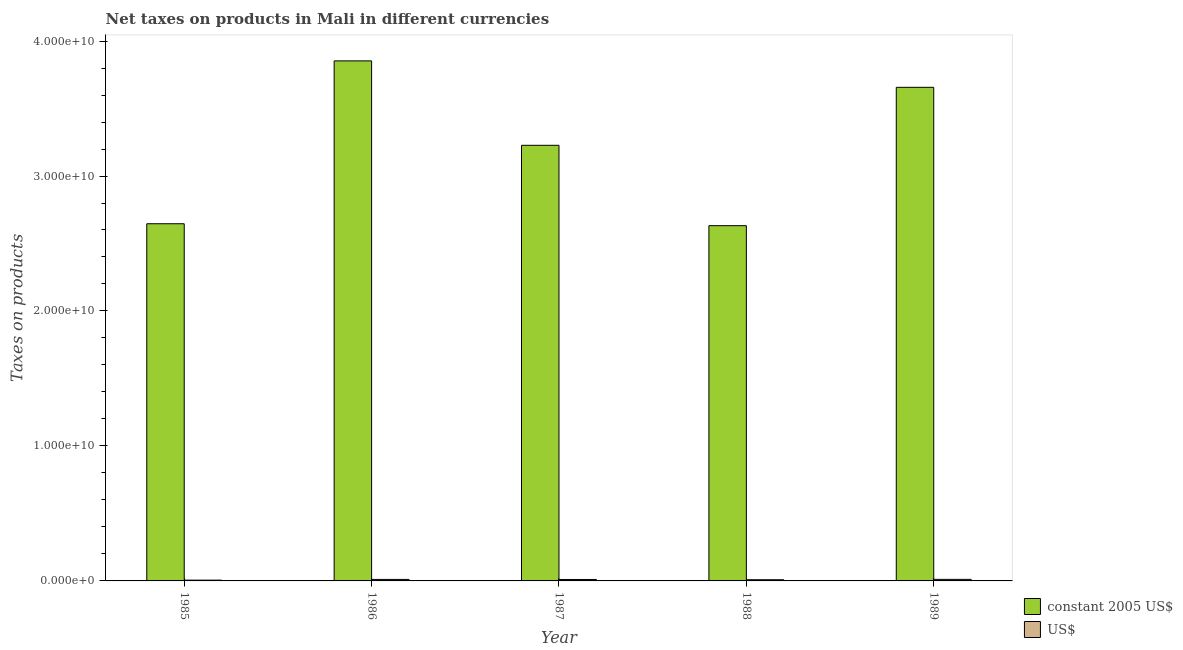How many different coloured bars are there?
Offer a very short reply. 2. How many groups of bars are there?
Give a very brief answer. 5. Are the number of bars on each tick of the X-axis equal?
Provide a short and direct response. Yes. How many bars are there on the 5th tick from the left?
Ensure brevity in your answer.  2. What is the net taxes in constant 2005 us$ in 1986?
Keep it short and to the point. 3.85e+1. Across all years, what is the maximum net taxes in us$?
Your answer should be very brief. 1.15e+08. Across all years, what is the minimum net taxes in constant 2005 us$?
Ensure brevity in your answer.  2.63e+1. In which year was the net taxes in constant 2005 us$ minimum?
Your response must be concise. 1988. What is the total net taxes in us$ in the graph?
Ensure brevity in your answer.  4.81e+08. What is the difference between the net taxes in constant 2005 us$ in 1986 and that in 1988?
Your response must be concise. 1.22e+1. What is the difference between the net taxes in us$ in 1988 and the net taxes in constant 2005 us$ in 1989?
Offer a terse response. -2.63e+07. What is the average net taxes in constant 2005 us$ per year?
Make the answer very short. 3.20e+1. In how many years, is the net taxes in us$ greater than 38000000000 units?
Keep it short and to the point. 0. What is the ratio of the net taxes in constant 2005 us$ in 1986 to that in 1988?
Give a very brief answer. 1.46. Is the difference between the net taxes in us$ in 1985 and 1986 greater than the difference between the net taxes in constant 2005 us$ in 1985 and 1986?
Give a very brief answer. No. What is the difference between the highest and the second highest net taxes in us$?
Your response must be concise. 3.38e+06. What is the difference between the highest and the lowest net taxes in constant 2005 us$?
Keep it short and to the point. 1.22e+1. In how many years, is the net taxes in us$ greater than the average net taxes in us$ taken over all years?
Offer a very short reply. 3. What does the 1st bar from the left in 1988 represents?
Your answer should be compact. Constant 2005 us$. What does the 2nd bar from the right in 1987 represents?
Your answer should be very brief. Constant 2005 us$. How many bars are there?
Make the answer very short. 10. Are all the bars in the graph horizontal?
Your response must be concise. No. What is the difference between two consecutive major ticks on the Y-axis?
Ensure brevity in your answer.  1.00e+1. Does the graph contain grids?
Your answer should be very brief. No. Where does the legend appear in the graph?
Give a very brief answer. Bottom right. How many legend labels are there?
Keep it short and to the point. 2. How are the legend labels stacked?
Provide a succinct answer. Vertical. What is the title of the graph?
Provide a succinct answer. Net taxes on products in Mali in different currencies. What is the label or title of the Y-axis?
Keep it short and to the point. Taxes on products. What is the Taxes on products of constant 2005 US$ in 1985?
Your response must be concise. 2.65e+1. What is the Taxes on products of US$ in 1985?
Provide a succinct answer. 5.89e+07. What is the Taxes on products of constant 2005 US$ in 1986?
Ensure brevity in your answer.  3.85e+1. What is the Taxes on products of US$ in 1986?
Give a very brief answer. 1.11e+08. What is the Taxes on products in constant 2005 US$ in 1987?
Keep it short and to the point. 3.23e+1. What is the Taxes on products in US$ in 1987?
Provide a short and direct response. 1.07e+08. What is the Taxes on products of constant 2005 US$ in 1988?
Your answer should be very brief. 2.63e+1. What is the Taxes on products in US$ in 1988?
Give a very brief answer. 8.84e+07. What is the Taxes on products of constant 2005 US$ in 1989?
Provide a short and direct response. 3.66e+1. What is the Taxes on products of US$ in 1989?
Your answer should be very brief. 1.15e+08. Across all years, what is the maximum Taxes on products of constant 2005 US$?
Give a very brief answer. 3.85e+1. Across all years, what is the maximum Taxes on products of US$?
Offer a terse response. 1.15e+08. Across all years, what is the minimum Taxes on products of constant 2005 US$?
Keep it short and to the point. 2.63e+1. Across all years, what is the minimum Taxes on products of US$?
Provide a succinct answer. 5.89e+07. What is the total Taxes on products of constant 2005 US$ in the graph?
Your answer should be very brief. 1.60e+11. What is the total Taxes on products in US$ in the graph?
Offer a terse response. 4.81e+08. What is the difference between the Taxes on products of constant 2005 US$ in 1985 and that in 1986?
Keep it short and to the point. -1.21e+1. What is the difference between the Taxes on products in US$ in 1985 and that in 1986?
Keep it short and to the point. -5.24e+07. What is the difference between the Taxes on products in constant 2005 US$ in 1985 and that in 1987?
Give a very brief answer. -5.81e+09. What is the difference between the Taxes on products in US$ in 1985 and that in 1987?
Provide a short and direct response. -4.85e+07. What is the difference between the Taxes on products of constant 2005 US$ in 1985 and that in 1988?
Give a very brief answer. 1.43e+08. What is the difference between the Taxes on products in US$ in 1985 and that in 1988?
Give a very brief answer. -2.95e+07. What is the difference between the Taxes on products of constant 2005 US$ in 1985 and that in 1989?
Provide a succinct answer. -1.01e+1. What is the difference between the Taxes on products of US$ in 1985 and that in 1989?
Give a very brief answer. -5.57e+07. What is the difference between the Taxes on products in constant 2005 US$ in 1986 and that in 1987?
Offer a very short reply. 6.26e+09. What is the difference between the Taxes on products of US$ in 1986 and that in 1987?
Your answer should be compact. 3.87e+06. What is the difference between the Taxes on products in constant 2005 US$ in 1986 and that in 1988?
Provide a succinct answer. 1.22e+1. What is the difference between the Taxes on products of US$ in 1986 and that in 1988?
Your answer should be compact. 2.29e+07. What is the difference between the Taxes on products of constant 2005 US$ in 1986 and that in 1989?
Make the answer very short. 1.96e+09. What is the difference between the Taxes on products in US$ in 1986 and that in 1989?
Give a very brief answer. -3.38e+06. What is the difference between the Taxes on products of constant 2005 US$ in 1987 and that in 1988?
Your response must be concise. 5.96e+09. What is the difference between the Taxes on products of US$ in 1987 and that in 1988?
Make the answer very short. 1.90e+07. What is the difference between the Taxes on products of constant 2005 US$ in 1987 and that in 1989?
Offer a very short reply. -4.30e+09. What is the difference between the Taxes on products of US$ in 1987 and that in 1989?
Offer a very short reply. -7.25e+06. What is the difference between the Taxes on products of constant 2005 US$ in 1988 and that in 1989?
Your answer should be compact. -1.03e+1. What is the difference between the Taxes on products of US$ in 1988 and that in 1989?
Offer a terse response. -2.63e+07. What is the difference between the Taxes on products in constant 2005 US$ in 1985 and the Taxes on products in US$ in 1986?
Your answer should be very brief. 2.64e+1. What is the difference between the Taxes on products in constant 2005 US$ in 1985 and the Taxes on products in US$ in 1987?
Your answer should be very brief. 2.64e+1. What is the difference between the Taxes on products of constant 2005 US$ in 1985 and the Taxes on products of US$ in 1988?
Your response must be concise. 2.64e+1. What is the difference between the Taxes on products in constant 2005 US$ in 1985 and the Taxes on products in US$ in 1989?
Your response must be concise. 2.63e+1. What is the difference between the Taxes on products of constant 2005 US$ in 1986 and the Taxes on products of US$ in 1987?
Your answer should be compact. 3.84e+1. What is the difference between the Taxes on products of constant 2005 US$ in 1986 and the Taxes on products of US$ in 1988?
Offer a terse response. 3.84e+1. What is the difference between the Taxes on products in constant 2005 US$ in 1986 and the Taxes on products in US$ in 1989?
Make the answer very short. 3.84e+1. What is the difference between the Taxes on products in constant 2005 US$ in 1987 and the Taxes on products in US$ in 1988?
Offer a terse response. 3.22e+1. What is the difference between the Taxes on products in constant 2005 US$ in 1987 and the Taxes on products in US$ in 1989?
Keep it short and to the point. 3.22e+1. What is the difference between the Taxes on products in constant 2005 US$ in 1988 and the Taxes on products in US$ in 1989?
Keep it short and to the point. 2.62e+1. What is the average Taxes on products in constant 2005 US$ per year?
Ensure brevity in your answer.  3.20e+1. What is the average Taxes on products of US$ per year?
Offer a very short reply. 9.61e+07. In the year 1985, what is the difference between the Taxes on products of constant 2005 US$ and Taxes on products of US$?
Offer a terse response. 2.64e+1. In the year 1986, what is the difference between the Taxes on products in constant 2005 US$ and Taxes on products in US$?
Keep it short and to the point. 3.84e+1. In the year 1987, what is the difference between the Taxes on products of constant 2005 US$ and Taxes on products of US$?
Provide a succinct answer. 3.22e+1. In the year 1988, what is the difference between the Taxes on products of constant 2005 US$ and Taxes on products of US$?
Your response must be concise. 2.62e+1. In the year 1989, what is the difference between the Taxes on products in constant 2005 US$ and Taxes on products in US$?
Your answer should be very brief. 3.65e+1. What is the ratio of the Taxes on products in constant 2005 US$ in 1985 to that in 1986?
Offer a very short reply. 0.69. What is the ratio of the Taxes on products of US$ in 1985 to that in 1986?
Your answer should be compact. 0.53. What is the ratio of the Taxes on products in constant 2005 US$ in 1985 to that in 1987?
Offer a terse response. 0.82. What is the ratio of the Taxes on products of US$ in 1985 to that in 1987?
Your response must be concise. 0.55. What is the ratio of the Taxes on products in constant 2005 US$ in 1985 to that in 1988?
Your answer should be compact. 1.01. What is the ratio of the Taxes on products of US$ in 1985 to that in 1988?
Your answer should be very brief. 0.67. What is the ratio of the Taxes on products of constant 2005 US$ in 1985 to that in 1989?
Your answer should be very brief. 0.72. What is the ratio of the Taxes on products of US$ in 1985 to that in 1989?
Give a very brief answer. 0.51. What is the ratio of the Taxes on products of constant 2005 US$ in 1986 to that in 1987?
Make the answer very short. 1.19. What is the ratio of the Taxes on products in US$ in 1986 to that in 1987?
Give a very brief answer. 1.04. What is the ratio of the Taxes on products in constant 2005 US$ in 1986 to that in 1988?
Make the answer very short. 1.46. What is the ratio of the Taxes on products in US$ in 1986 to that in 1988?
Ensure brevity in your answer.  1.26. What is the ratio of the Taxes on products in constant 2005 US$ in 1986 to that in 1989?
Provide a short and direct response. 1.05. What is the ratio of the Taxes on products of US$ in 1986 to that in 1989?
Provide a short and direct response. 0.97. What is the ratio of the Taxes on products in constant 2005 US$ in 1987 to that in 1988?
Ensure brevity in your answer.  1.23. What is the ratio of the Taxes on products in US$ in 1987 to that in 1988?
Give a very brief answer. 1.22. What is the ratio of the Taxes on products of constant 2005 US$ in 1987 to that in 1989?
Provide a short and direct response. 0.88. What is the ratio of the Taxes on products in US$ in 1987 to that in 1989?
Offer a very short reply. 0.94. What is the ratio of the Taxes on products of constant 2005 US$ in 1988 to that in 1989?
Your answer should be compact. 0.72. What is the ratio of the Taxes on products in US$ in 1988 to that in 1989?
Give a very brief answer. 0.77. What is the difference between the highest and the second highest Taxes on products of constant 2005 US$?
Your answer should be very brief. 1.96e+09. What is the difference between the highest and the second highest Taxes on products of US$?
Offer a terse response. 3.38e+06. What is the difference between the highest and the lowest Taxes on products of constant 2005 US$?
Ensure brevity in your answer.  1.22e+1. What is the difference between the highest and the lowest Taxes on products of US$?
Your answer should be very brief. 5.57e+07. 